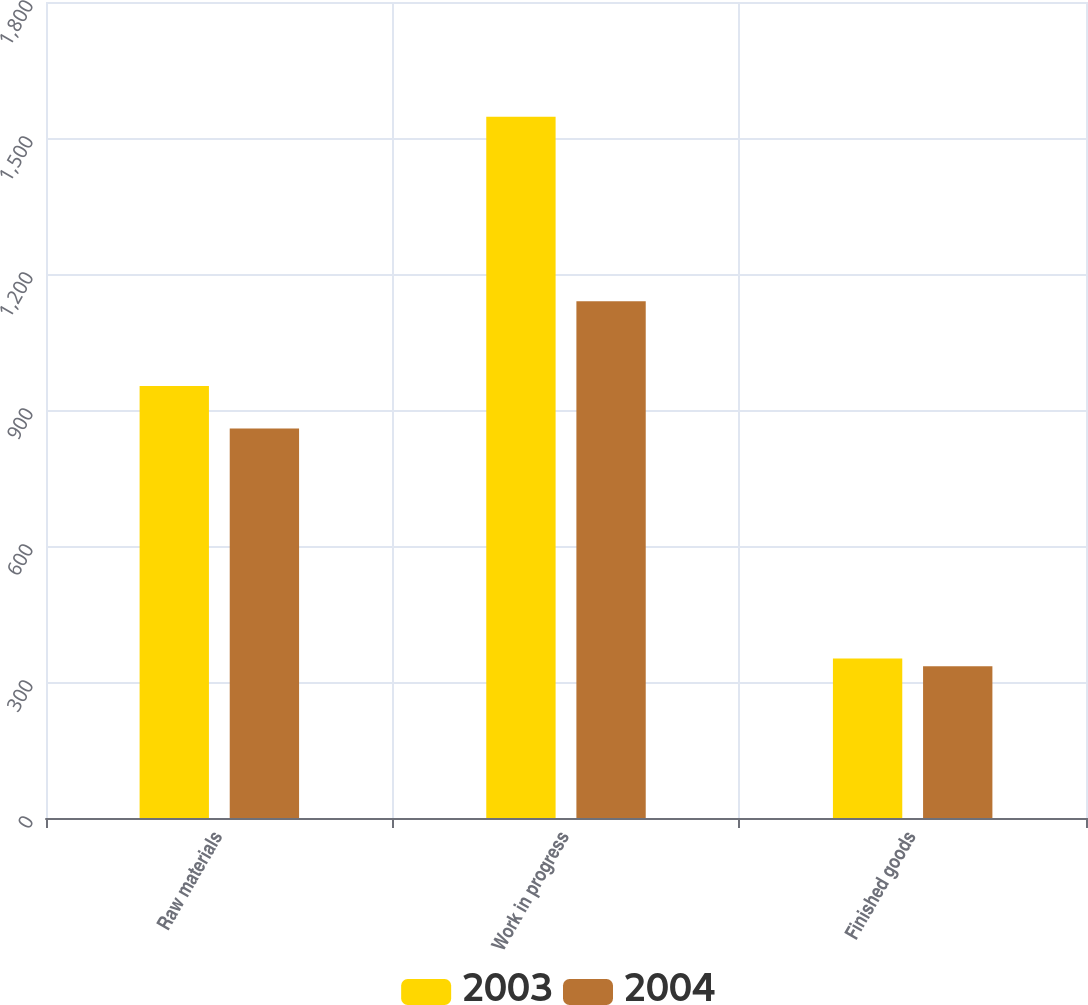<chart> <loc_0><loc_0><loc_500><loc_500><stacked_bar_chart><ecel><fcel>Raw materials<fcel>Work in progress<fcel>Finished goods<nl><fcel>2003<fcel>953<fcel>1547<fcel>352<nl><fcel>2004<fcel>859<fcel>1140<fcel>335<nl></chart> 